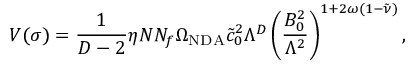Convert formula to latex. <formula><loc_0><loc_0><loc_500><loc_500>V ( \sigma ) = \frac { 1 } { D - 2 } \eta N N _ { f } \Omega _ { N D A } \tilde { c } _ { 0 } ^ { 2 } \Lambda ^ { D } \left ( \frac { B _ { 0 } ^ { 2 } } { \Lambda ^ { 2 } } \right ) ^ { 1 + 2 \omega ( 1 - \tilde { \nu } ) } ,</formula> 